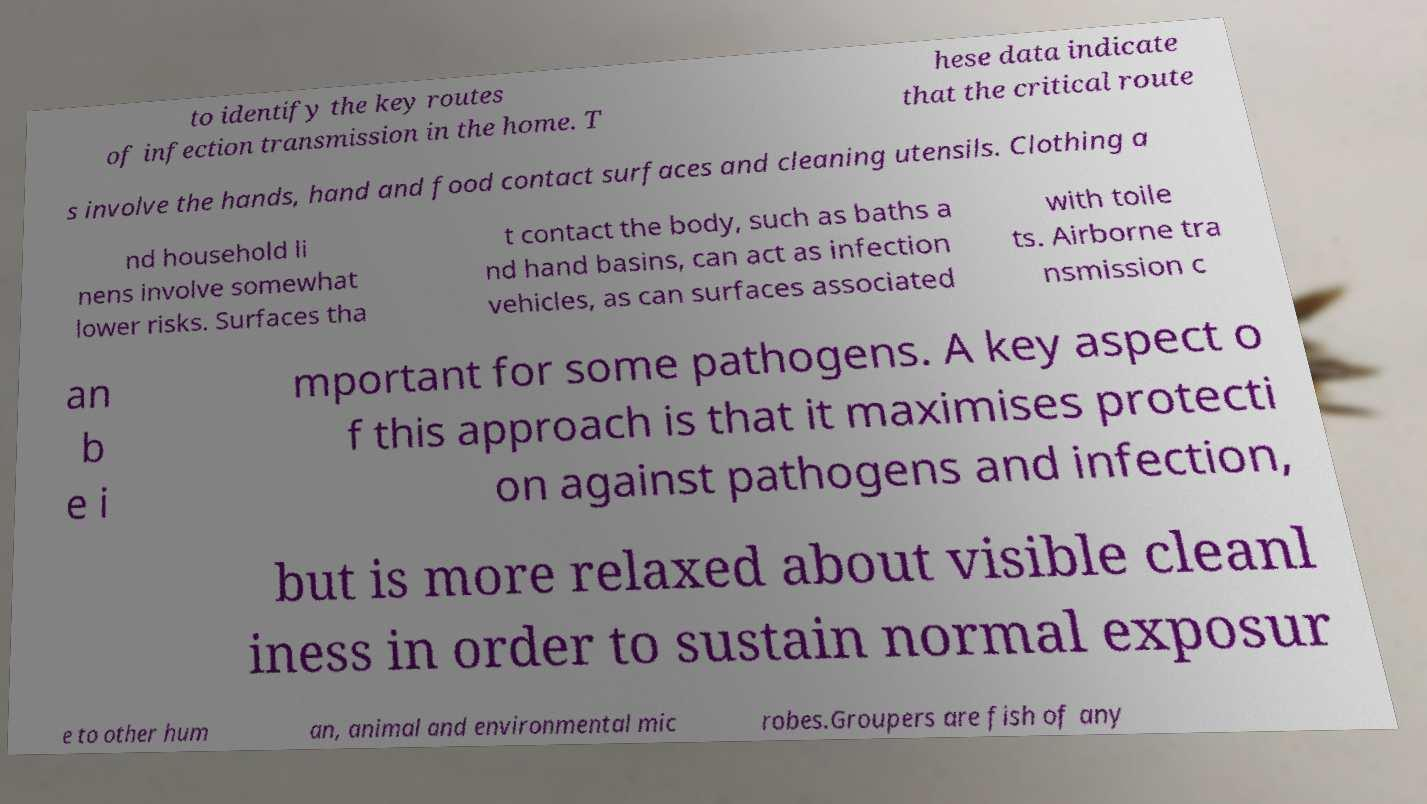Can you read and provide the text displayed in the image?This photo seems to have some interesting text. Can you extract and type it out for me? to identify the key routes of infection transmission in the home. T hese data indicate that the critical route s involve the hands, hand and food contact surfaces and cleaning utensils. Clothing a nd household li nens involve somewhat lower risks. Surfaces tha t contact the body, such as baths a nd hand basins, can act as infection vehicles, as can surfaces associated with toile ts. Airborne tra nsmission c an b e i mportant for some pathogens. A key aspect o f this approach is that it maximises protecti on against pathogens and infection, but is more relaxed about visible cleanl iness in order to sustain normal exposur e to other hum an, animal and environmental mic robes.Groupers are fish of any 